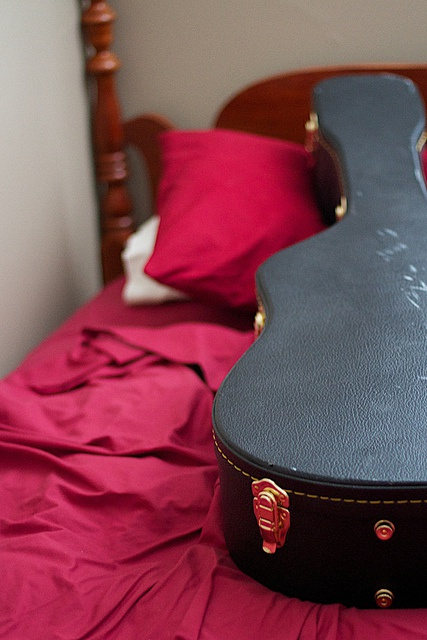Describe the objects in this image and their specific colors. I can see a bed in lightgray, brown, and maroon tones in this image. 